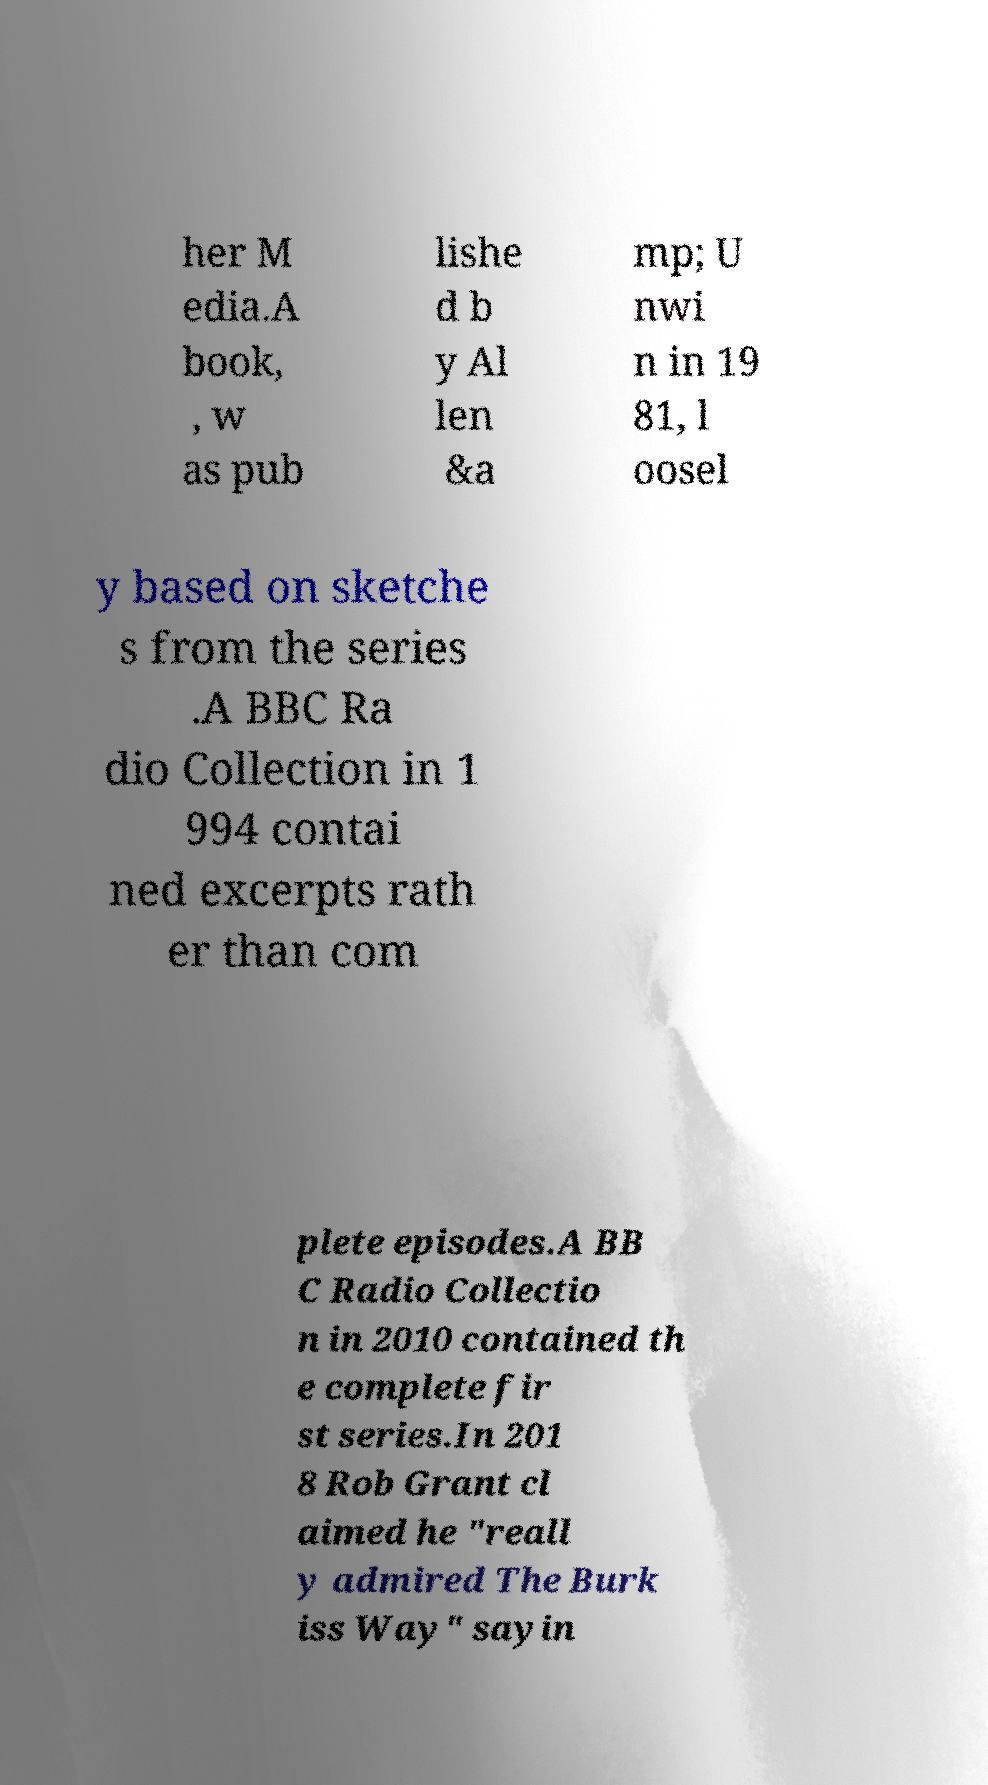For documentation purposes, I need the text within this image transcribed. Could you provide that? her M edia.A book, , w as pub lishe d b y Al len &a mp; U nwi n in 19 81, l oosel y based on sketche s from the series .A BBC Ra dio Collection in 1 994 contai ned excerpts rath er than com plete episodes.A BB C Radio Collectio n in 2010 contained th e complete fir st series.In 201 8 Rob Grant cl aimed he "reall y admired The Burk iss Way" sayin 